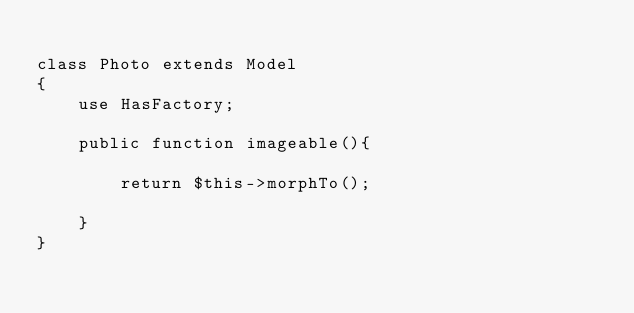Convert code to text. <code><loc_0><loc_0><loc_500><loc_500><_PHP_>
class Photo extends Model
{
    use HasFactory;

    public function imageable(){

        return $this->morphTo();

    }
}
</code> 